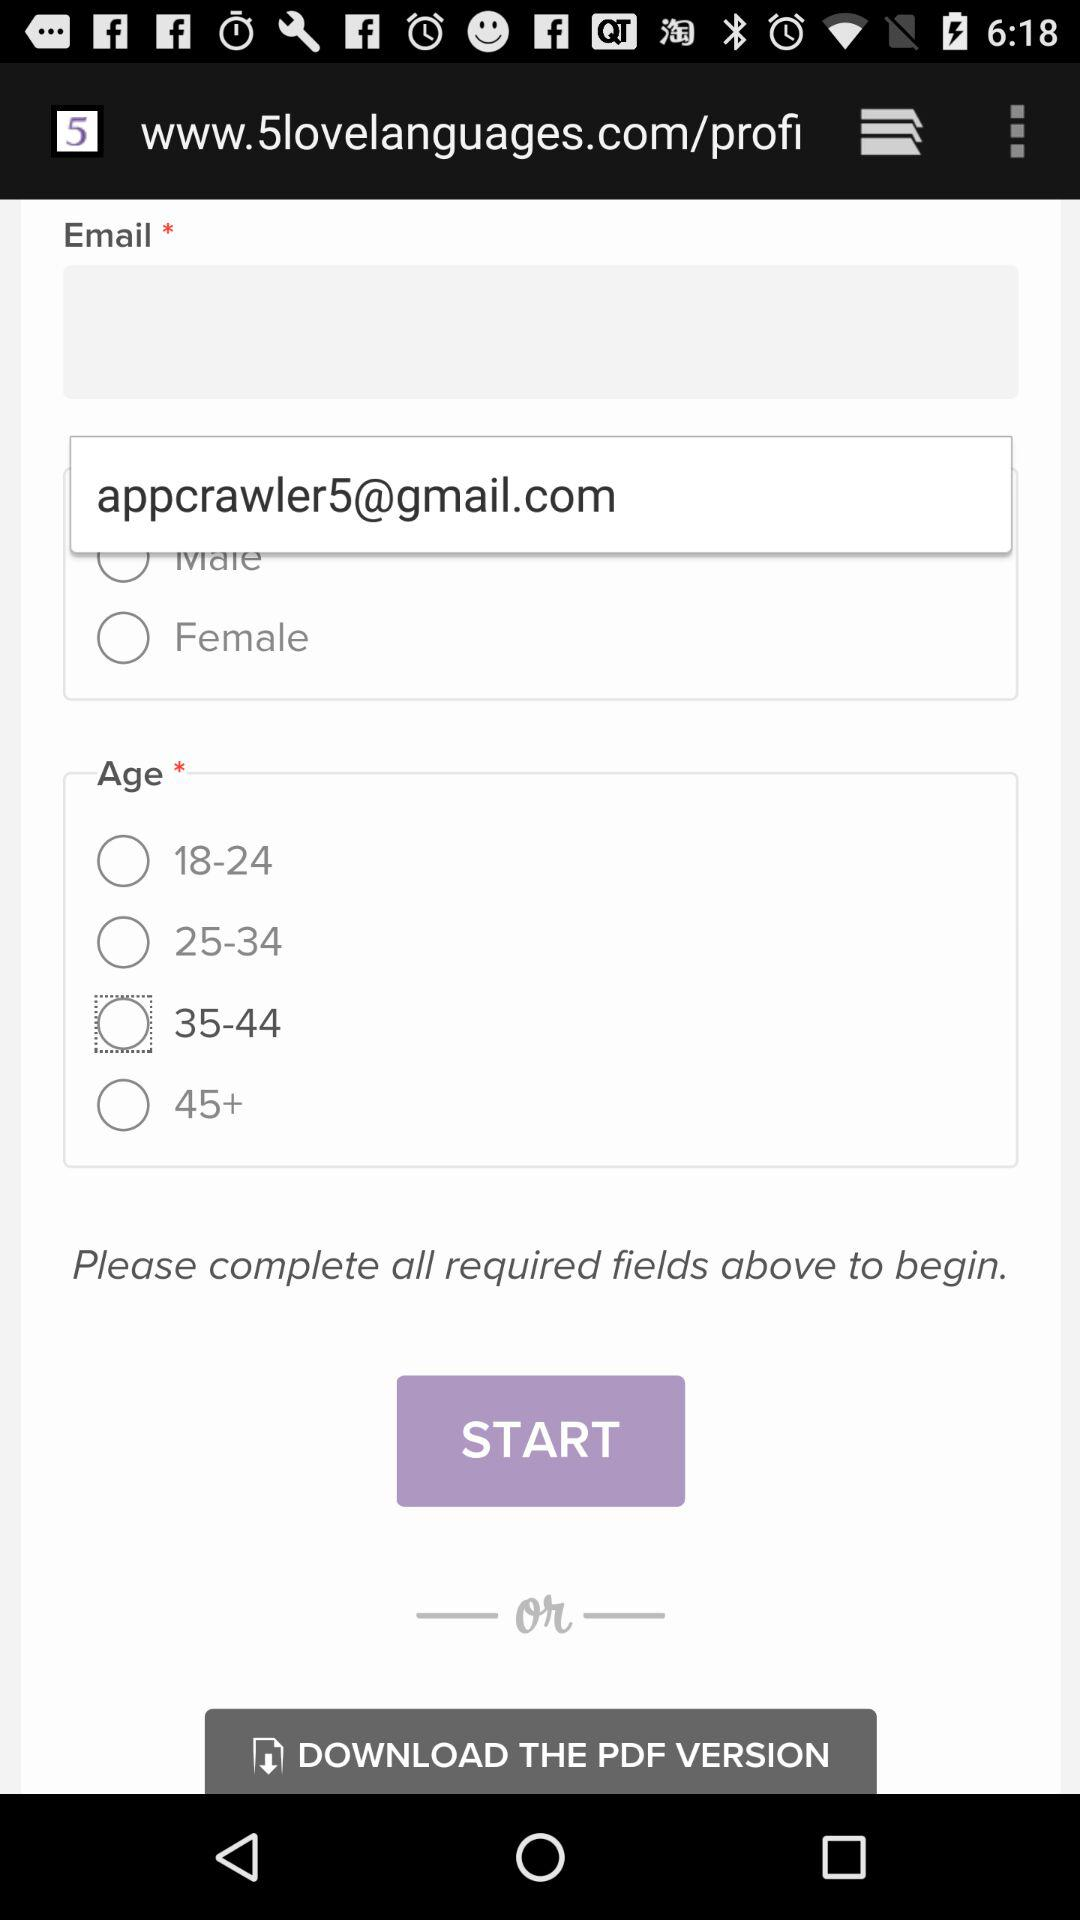What is the Gmail account? The Gmail account is appcrawler5@gmail.com. 